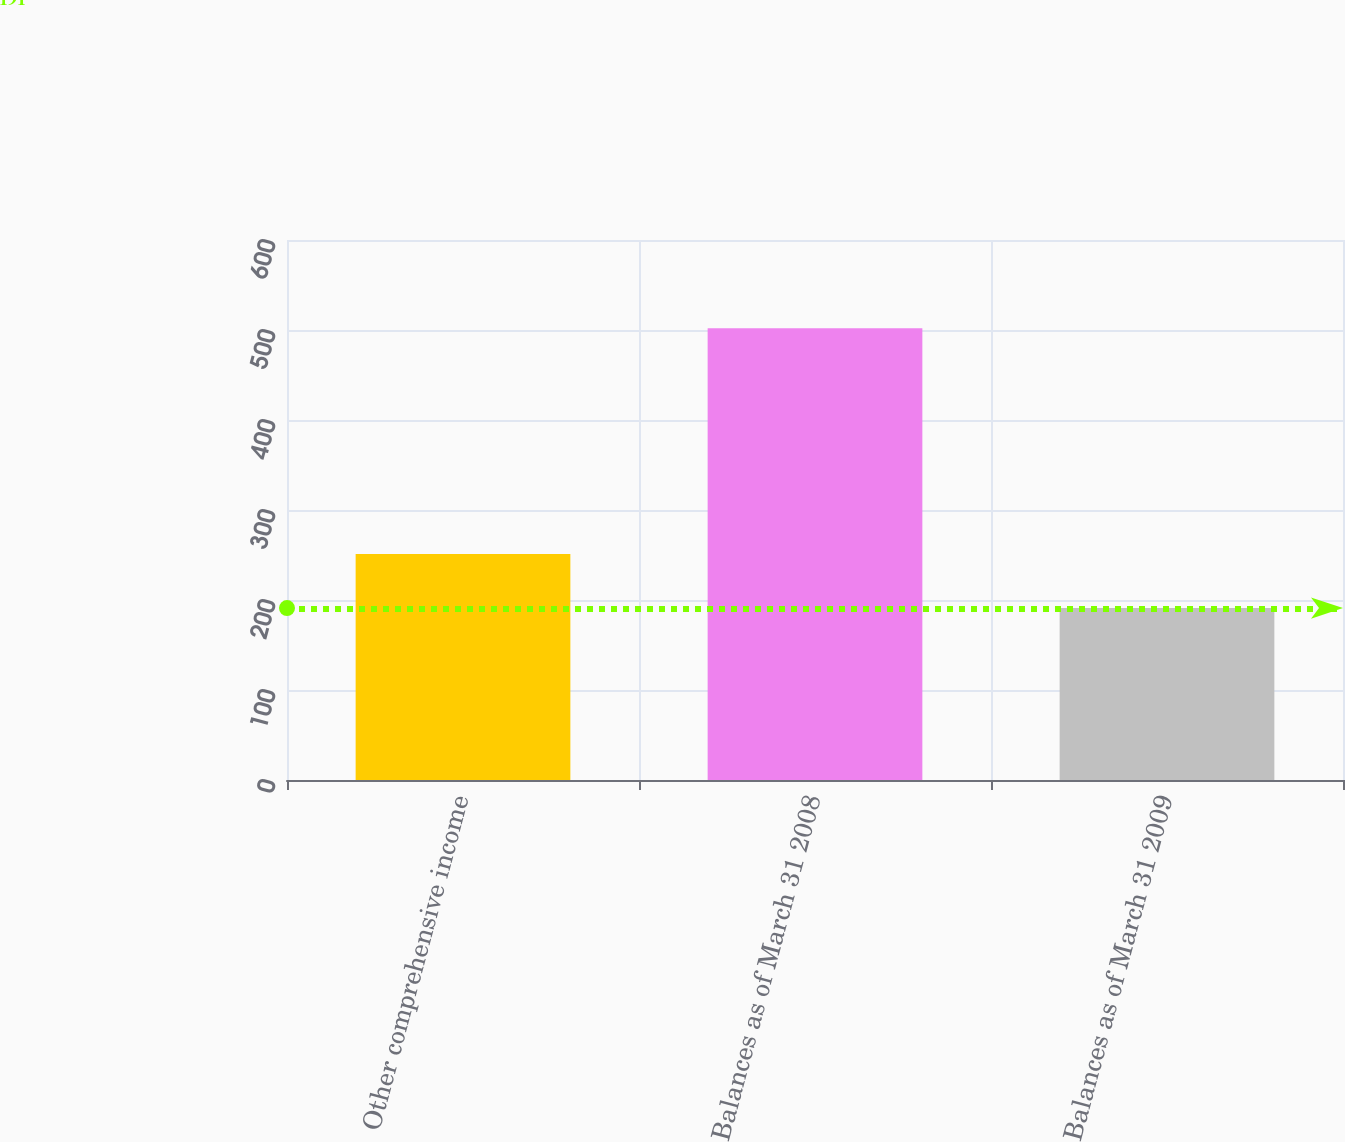<chart> <loc_0><loc_0><loc_500><loc_500><bar_chart><fcel>Other comprehensive income<fcel>Balances as of March 31 2008<fcel>Balances as of March 31 2009<nl><fcel>251<fcel>502<fcel>191<nl></chart> 